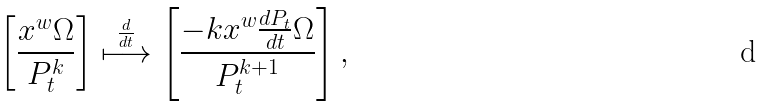<formula> <loc_0><loc_0><loc_500><loc_500>\left [ \frac { x ^ { w } \Omega } { P _ { t } ^ { k } } \right ] \stackrel { \frac { d } { d t } } { \longmapsto } \left [ \frac { - k x ^ { w } \frac { d P _ { t } } { d t } \Omega } { P _ { t } ^ { k + 1 } } \right ] ,</formula> 